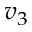<formula> <loc_0><loc_0><loc_500><loc_500>v _ { 3 }</formula> 